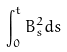<formula> <loc_0><loc_0><loc_500><loc_500>\int _ { 0 } ^ { t } B _ { s } ^ { 2 } d s</formula> 